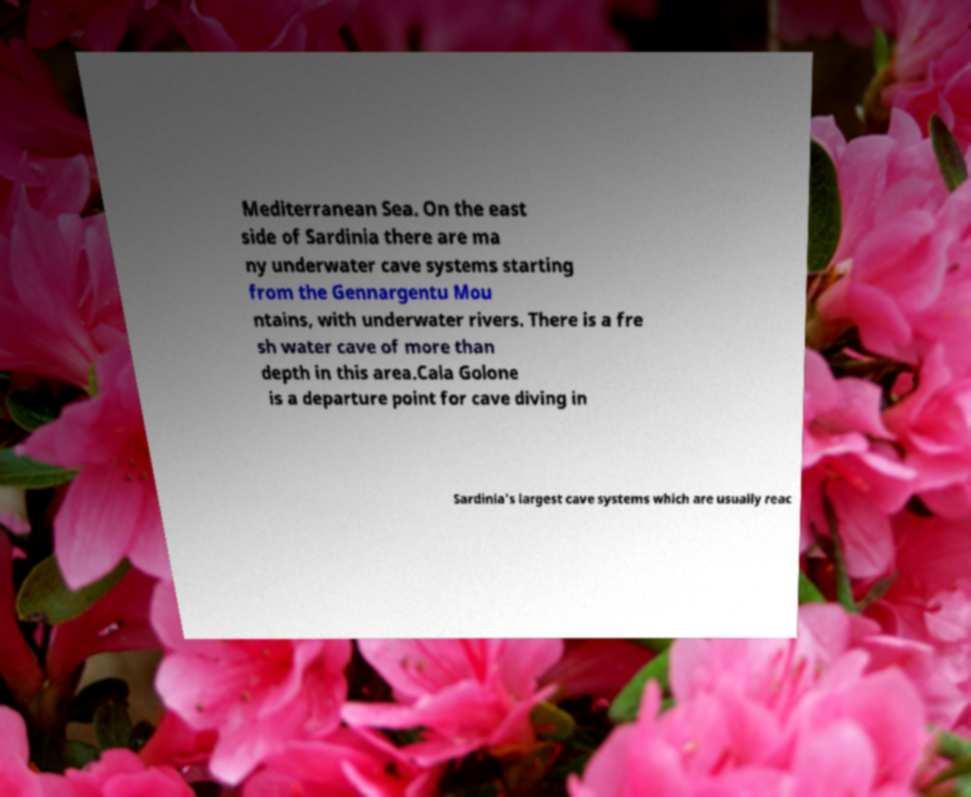There's text embedded in this image that I need extracted. Can you transcribe it verbatim? Mediterranean Sea. On the east side of Sardinia there are ma ny underwater cave systems starting from the Gennargentu Mou ntains, with underwater rivers. There is a fre sh water cave of more than depth in this area.Cala Golone is a departure point for cave diving in Sardinia's largest cave systems which are usually reac 